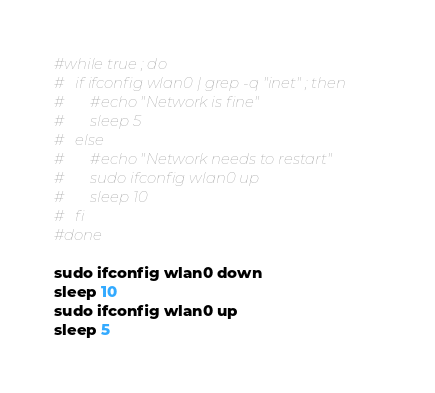<code> <loc_0><loc_0><loc_500><loc_500><_Bash_>
#while true ; do
#	if ifconfig wlan0 | grep -q "inet" ; then
#		#echo "Network is fine"
#		sleep 5
#	else
#		#echo "Network needs to restart"
#		sudo ifconfig wlan0 up
#		sleep 10
#	fi
#done

sudo ifconfig wlan0 down
sleep 10
sudo ifconfig wlan0 up
sleep 5</code> 